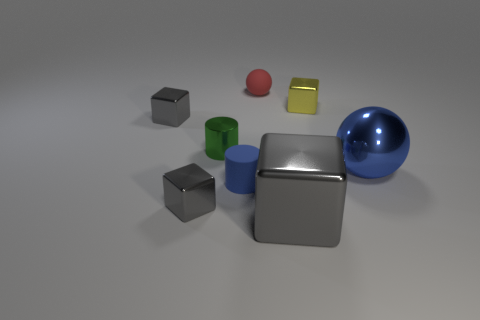There is a block that is to the right of the small green thing and in front of the small yellow shiny thing; what is its color?
Offer a very short reply. Gray. What is the size of the gray metallic cube that is behind the big blue sphere?
Offer a terse response. Small. What number of objects are the same material as the red sphere?
Provide a succinct answer. 1. The thing that is the same color as the matte cylinder is what shape?
Your answer should be very brief. Sphere. There is a tiny thing that is on the right side of the red ball; is its shape the same as the small green thing?
Ensure brevity in your answer.  No. There is a cylinder that is the same material as the large gray cube; what is its color?
Your answer should be compact. Green. There is a large object to the left of the large object that is to the right of the yellow metallic thing; are there any small cubes to the right of it?
Provide a short and direct response. Yes. What is the shape of the small green shiny object?
Your answer should be very brief. Cylinder. Are there fewer tiny red things to the left of the small red thing than blue spheres?
Your answer should be very brief. Yes. Are there any blue matte objects of the same shape as the green shiny thing?
Keep it short and to the point. Yes. 